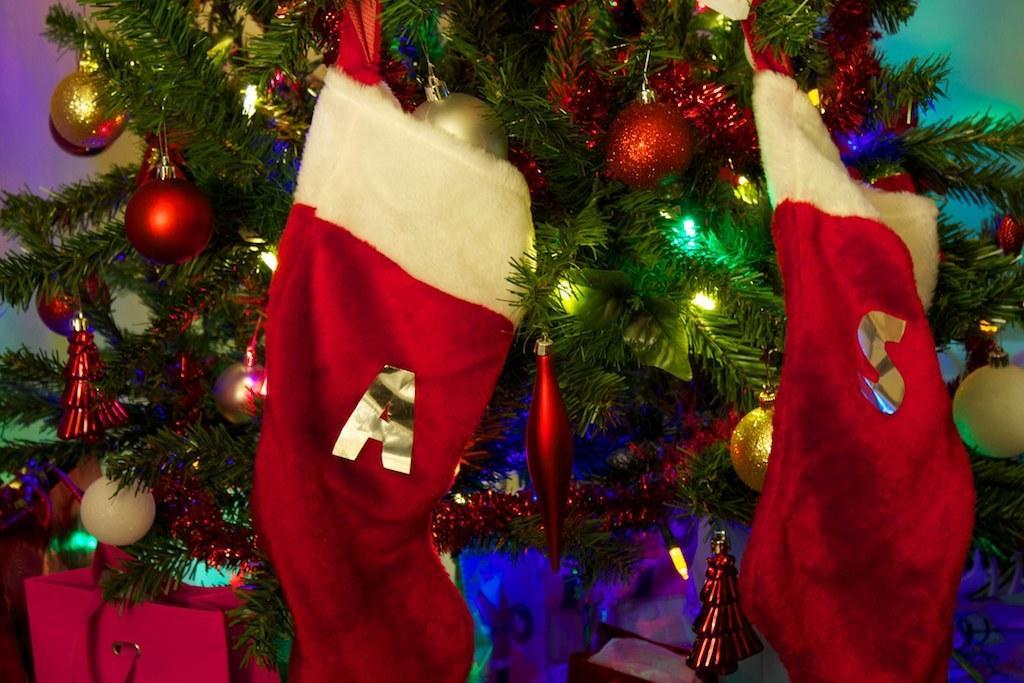Can you describe this image briefly? In this picture we can see colorful Christmas tree, on which we can see some lights, balls, caps and we can see a bag. 